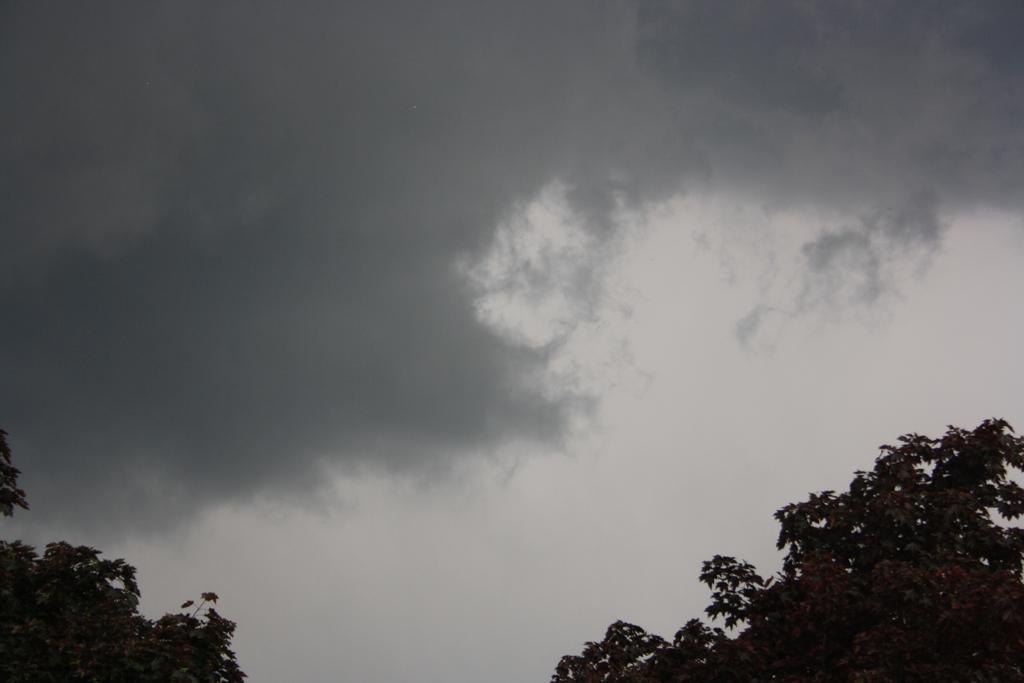Could you give a brief overview of what you see in this image? This picture is taken outside. At the bottom left and at the bottom right there are trees. On the top, there is a sky with clouds. 